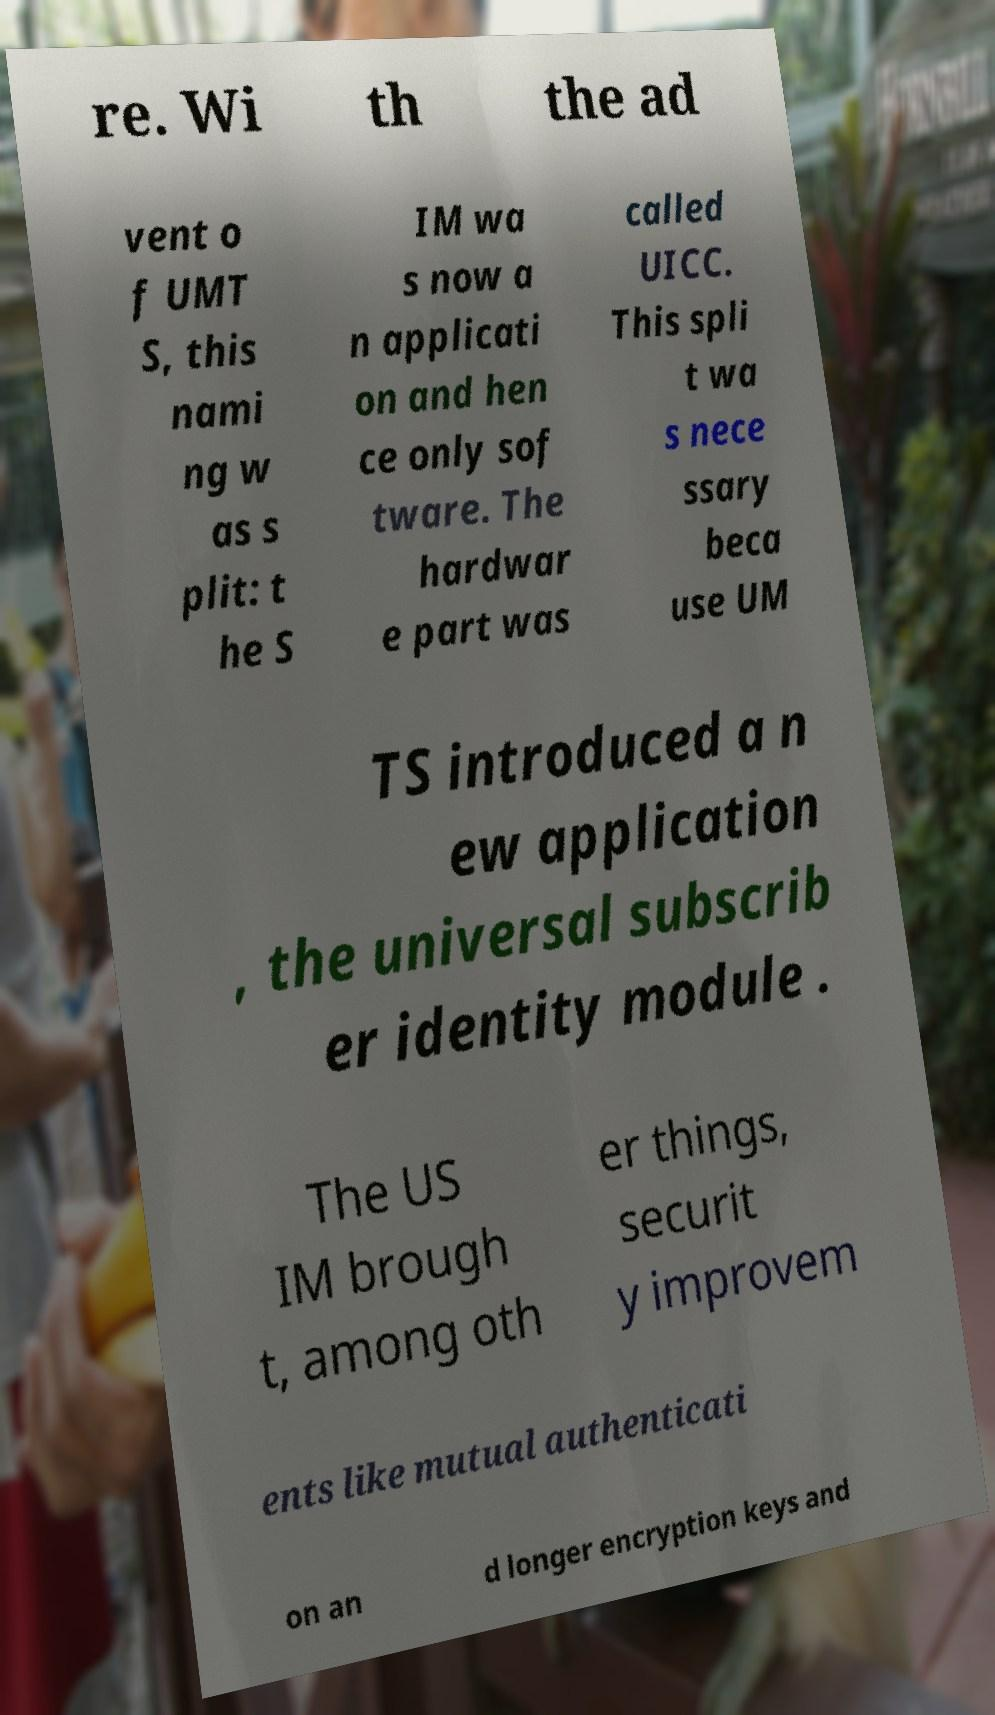There's text embedded in this image that I need extracted. Can you transcribe it verbatim? re. Wi th the ad vent o f UMT S, this nami ng w as s plit: t he S IM wa s now a n applicati on and hen ce only sof tware. The hardwar e part was called UICC. This spli t wa s nece ssary beca use UM TS introduced a n ew application , the universal subscrib er identity module . The US IM brough t, among oth er things, securit y improvem ents like mutual authenticati on an d longer encryption keys and 